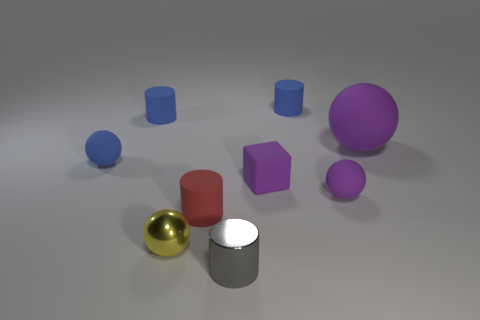Subtract all blue spheres. How many spheres are left? 3 Subtract all red cylinders. How many cylinders are left? 3 Subtract all cylinders. How many objects are left? 5 Subtract all blue cylinders. How many yellow spheres are left? 1 Add 2 cylinders. How many cylinders are left? 6 Add 3 big blue matte cubes. How many big blue matte cubes exist? 3 Subtract 0 cyan blocks. How many objects are left? 9 Subtract 3 cylinders. How many cylinders are left? 1 Subtract all blue cylinders. Subtract all green blocks. How many cylinders are left? 2 Subtract all tiny green metal blocks. Subtract all tiny blue matte cylinders. How many objects are left? 7 